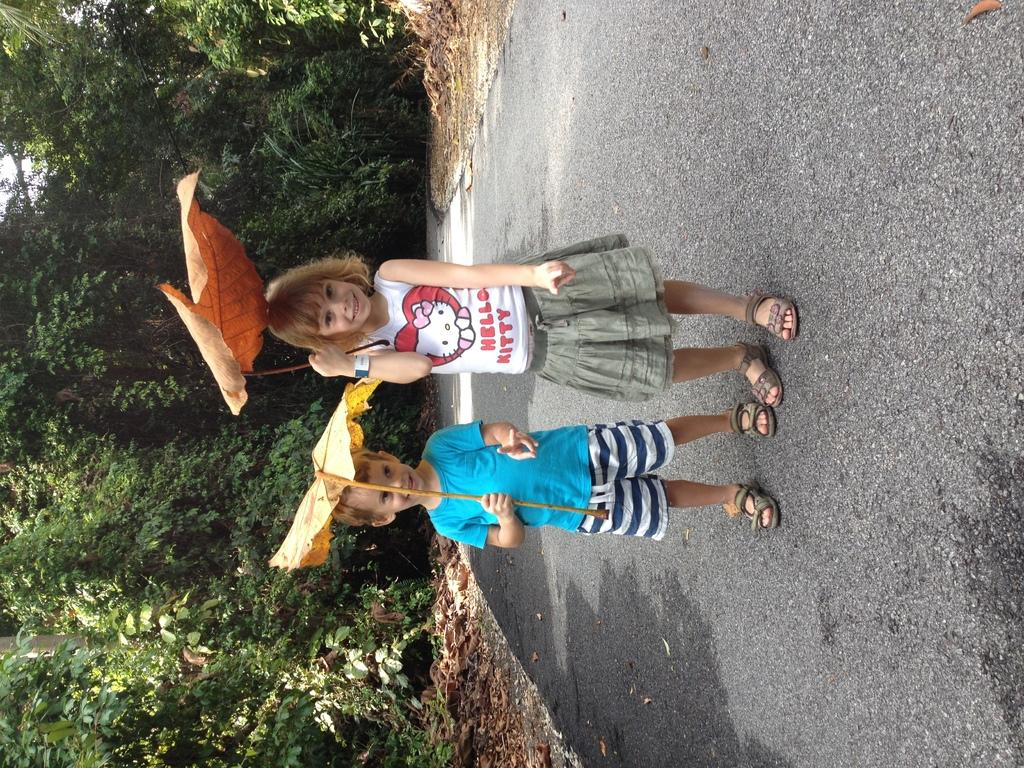Provide a one-sentence caption for the provided image. Two young children smile as they hold giant leaves over their heads, the girl in a Hello Kitty shirt. 